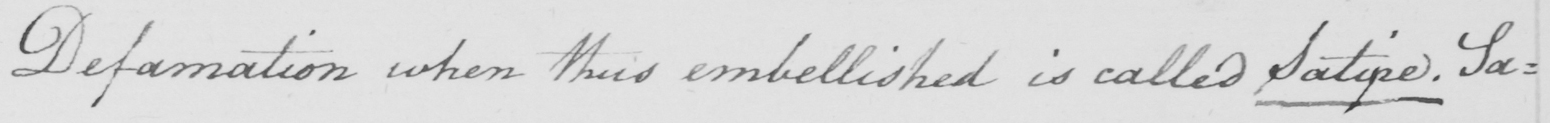What text is written in this handwritten line? Defamation when thus embellished is called Satire . Sa : 